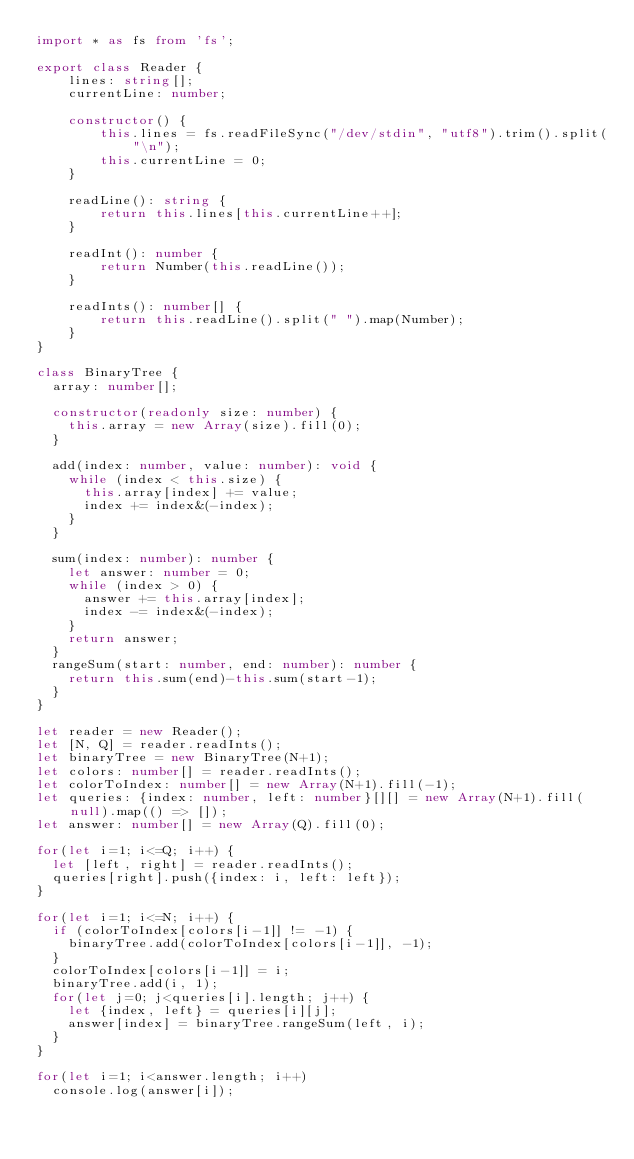Convert code to text. <code><loc_0><loc_0><loc_500><loc_500><_TypeScript_>import * as fs from 'fs';

export class Reader {
    lines: string[];
    currentLine: number;

    constructor() {
        this.lines = fs.readFileSync("/dev/stdin", "utf8").trim().split("\n");
        this.currentLine = 0;
    }

    readLine(): string {
        return this.lines[this.currentLine++];
    }

    readInt(): number {
        return Number(this.readLine());
    }

    readInts(): number[] {
        return this.readLine().split(" ").map(Number);
    }
}

class BinaryTree {
	array: number[];

	constructor(readonly size: number) {
		this.array = new Array(size).fill(0);
	}

	add(index: number, value: number): void {
		while (index < this.size) {
			this.array[index] += value;
			index += index&(-index);
		}
	}

	sum(index: number): number {
		let answer: number = 0;
		while (index > 0) {
			answer += this.array[index];
			index -= index&(-index);
		}
		return answer;
	}
	rangeSum(start: number, end: number): number {
		return this.sum(end)-this.sum(start-1);
	}
}

let reader = new Reader();
let [N, Q] = reader.readInts();
let binaryTree = new BinaryTree(N+1);
let colors: number[] = reader.readInts();
let colorToIndex: number[] = new Array(N+1).fill(-1);
let queries: {index: number, left: number}[][] = new Array(N+1).fill(null).map(() => []);
let answer: number[] = new Array(Q).fill(0);

for(let i=1; i<=Q; i++) {
	let [left, right] = reader.readInts();
	queries[right].push({index: i, left: left});
}

for(let i=1; i<=N; i++) {
	if (colorToIndex[colors[i-1]] != -1) {
		binaryTree.add(colorToIndex[colors[i-1]], -1);
	}
	colorToIndex[colors[i-1]] = i;
	binaryTree.add(i, 1);
	for(let j=0; j<queries[i].length; j++) {
		let {index, left} = queries[i][j];
		answer[index] = binaryTree.rangeSum(left, i);
	}
}

for(let i=1; i<answer.length; i++)
	console.log(answer[i]);
</code> 